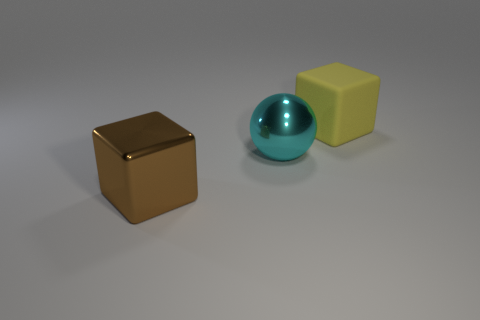Add 2 yellow objects. How many objects exist? 5 Subtract all spheres. How many objects are left? 2 Add 3 large cyan metallic things. How many large cyan metallic things are left? 4 Add 2 large yellow rubber cubes. How many large yellow rubber cubes exist? 3 Subtract 0 blue blocks. How many objects are left? 3 Subtract all tiny things. Subtract all big brown metal blocks. How many objects are left? 2 